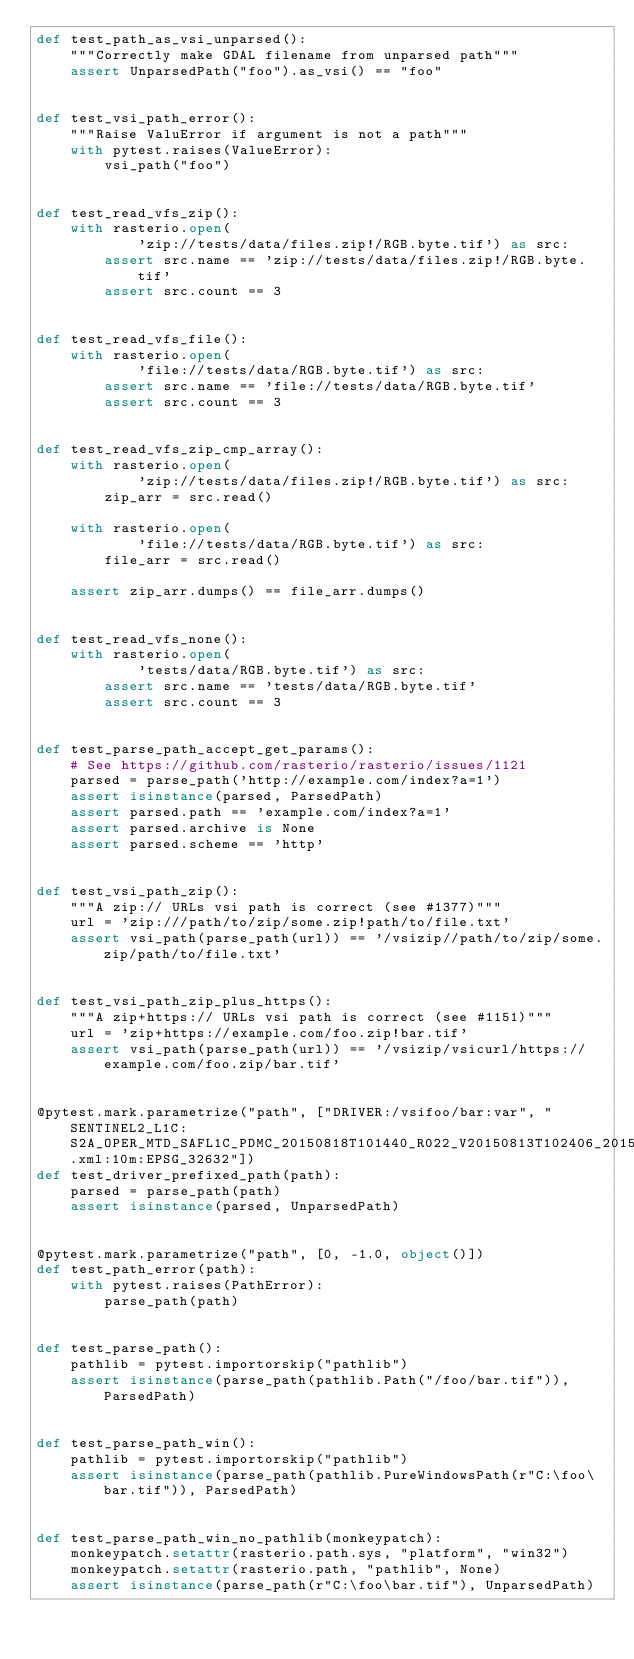<code> <loc_0><loc_0><loc_500><loc_500><_Python_>def test_path_as_vsi_unparsed():
    """Correctly make GDAL filename from unparsed path"""
    assert UnparsedPath("foo").as_vsi() == "foo"


def test_vsi_path_error():
    """Raise ValuError if argument is not a path"""
    with pytest.raises(ValueError):
        vsi_path("foo")


def test_read_vfs_zip():
    with rasterio.open(
            'zip://tests/data/files.zip!/RGB.byte.tif') as src:
        assert src.name == 'zip://tests/data/files.zip!/RGB.byte.tif'
        assert src.count == 3


def test_read_vfs_file():
    with rasterio.open(
            'file://tests/data/RGB.byte.tif') as src:
        assert src.name == 'file://tests/data/RGB.byte.tif'
        assert src.count == 3


def test_read_vfs_zip_cmp_array():
    with rasterio.open(
            'zip://tests/data/files.zip!/RGB.byte.tif') as src:
        zip_arr = src.read()

    with rasterio.open(
            'file://tests/data/RGB.byte.tif') as src:
        file_arr = src.read()

    assert zip_arr.dumps() == file_arr.dumps()


def test_read_vfs_none():
    with rasterio.open(
            'tests/data/RGB.byte.tif') as src:
        assert src.name == 'tests/data/RGB.byte.tif'
        assert src.count == 3


def test_parse_path_accept_get_params():
    # See https://github.com/rasterio/rasterio/issues/1121
    parsed = parse_path('http://example.com/index?a=1')
    assert isinstance(parsed, ParsedPath)
    assert parsed.path == 'example.com/index?a=1'
    assert parsed.archive is None
    assert parsed.scheme == 'http'


def test_vsi_path_zip():
    """A zip:// URLs vsi path is correct (see #1377)"""
    url = 'zip:///path/to/zip/some.zip!path/to/file.txt'
    assert vsi_path(parse_path(url)) == '/vsizip//path/to/zip/some.zip/path/to/file.txt'


def test_vsi_path_zip_plus_https():
    """A zip+https:// URLs vsi path is correct (see #1151)"""
    url = 'zip+https://example.com/foo.zip!bar.tif'
    assert vsi_path(parse_path(url)) == '/vsizip/vsicurl/https://example.com/foo.zip/bar.tif'


@pytest.mark.parametrize("path", ["DRIVER:/vsifoo/bar:var", "SENTINEL2_L1C:S2A_OPER_MTD_SAFL1C_PDMC_20150818T101440_R022_V20150813T102406_20150813T102406.xml:10m:EPSG_32632"])
def test_driver_prefixed_path(path):
    parsed = parse_path(path)
    assert isinstance(parsed, UnparsedPath)


@pytest.mark.parametrize("path", [0, -1.0, object()])
def test_path_error(path):
    with pytest.raises(PathError):
        parse_path(path)


def test_parse_path():
    pathlib = pytest.importorskip("pathlib")
    assert isinstance(parse_path(pathlib.Path("/foo/bar.tif")), ParsedPath)


def test_parse_path_win():
    pathlib = pytest.importorskip("pathlib")
    assert isinstance(parse_path(pathlib.PureWindowsPath(r"C:\foo\bar.tif")), ParsedPath)


def test_parse_path_win_no_pathlib(monkeypatch):
    monkeypatch.setattr(rasterio.path.sys, "platform", "win32")
    monkeypatch.setattr(rasterio.path, "pathlib", None)
    assert isinstance(parse_path(r"C:\foo\bar.tif"), UnparsedPath)
</code> 